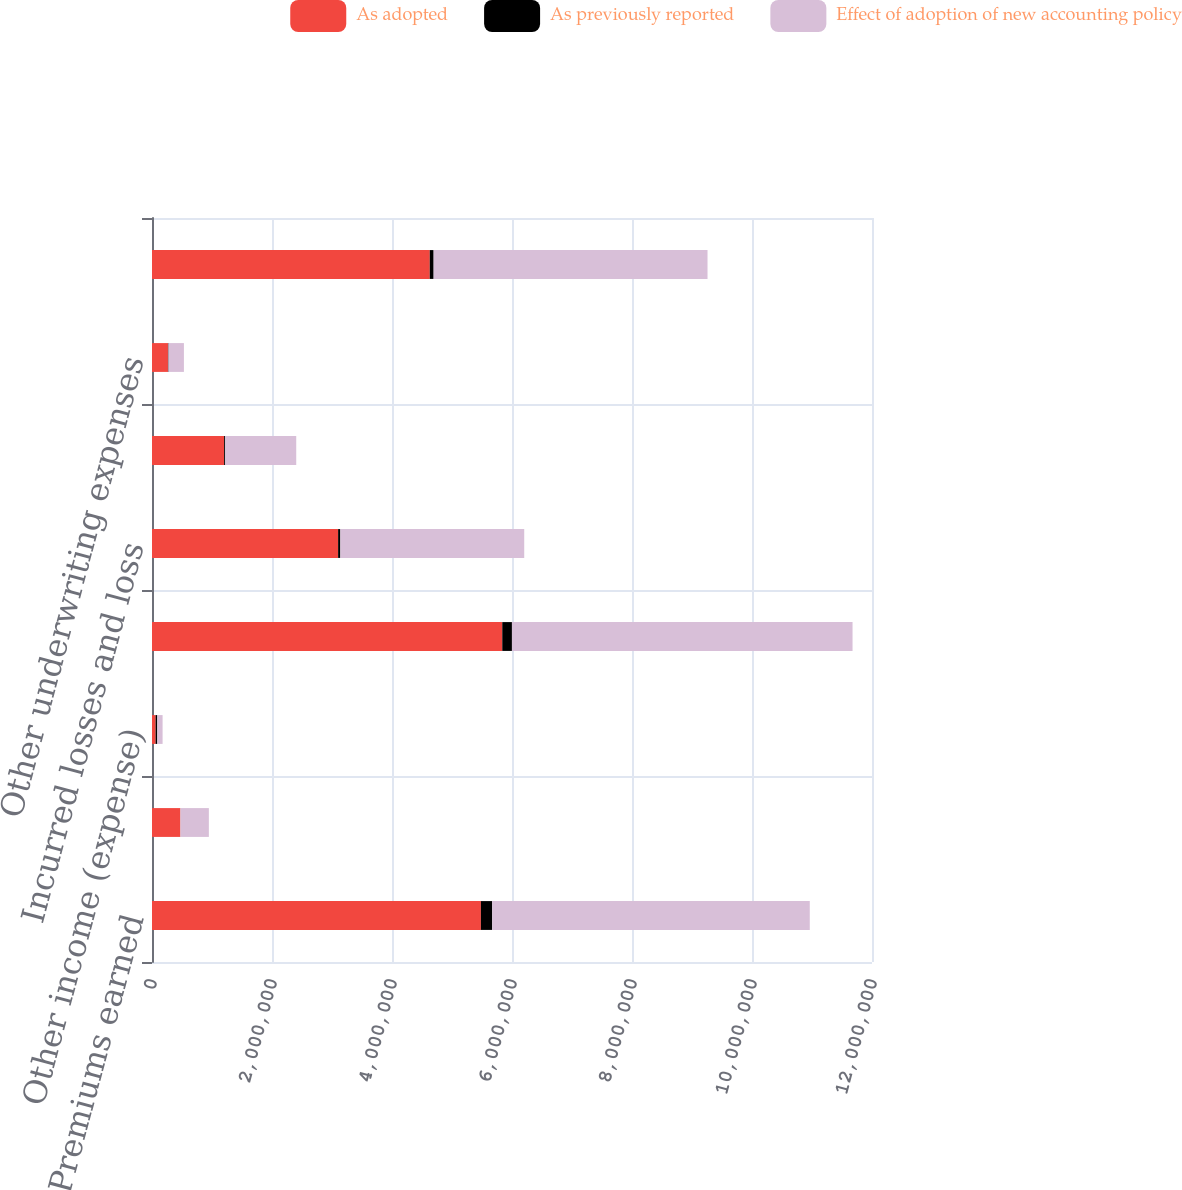Convert chart to OTSL. <chart><loc_0><loc_0><loc_500><loc_500><stacked_bar_chart><ecel><fcel>Premiums earned<fcel>Net investment income<fcel>Other income (expense)<fcel>Total revenues<fcel>Incurred losses and loss<fcel>Commission brokerage taxes and<fcel>Other underwriting expenses<fcel>Total claims and expenses<nl><fcel>As adopted<fcel>5.48146e+06<fcel>473825<fcel>60435<fcel>5.83789e+06<fcel>3.10192e+06<fcel>1.20204e+06<fcel>265984<fcel>4.62938e+06<nl><fcel>As previously reported<fcel>188617<fcel>352<fcel>27845<fcel>161124<fcel>37200<fcel>18390<fcel>8915<fcel>64505<nl><fcel>Effect of adoption of new accounting policy<fcel>5.29284e+06<fcel>473473<fcel>88280<fcel>5.67676e+06<fcel>3.06472e+06<fcel>1.18365e+06<fcel>257069<fcel>4.56488e+06<nl></chart> 